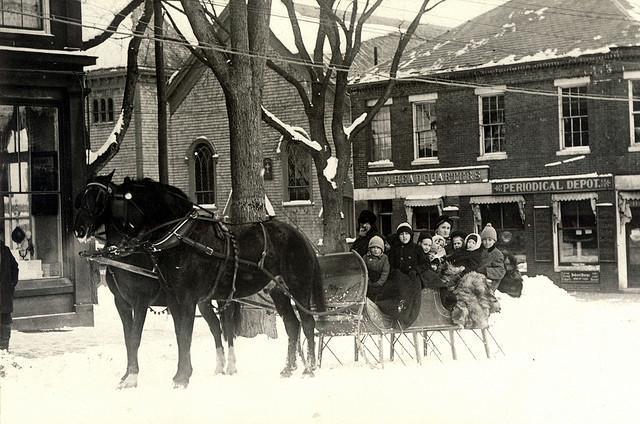How many horses can you see?
Give a very brief answer. 2. 